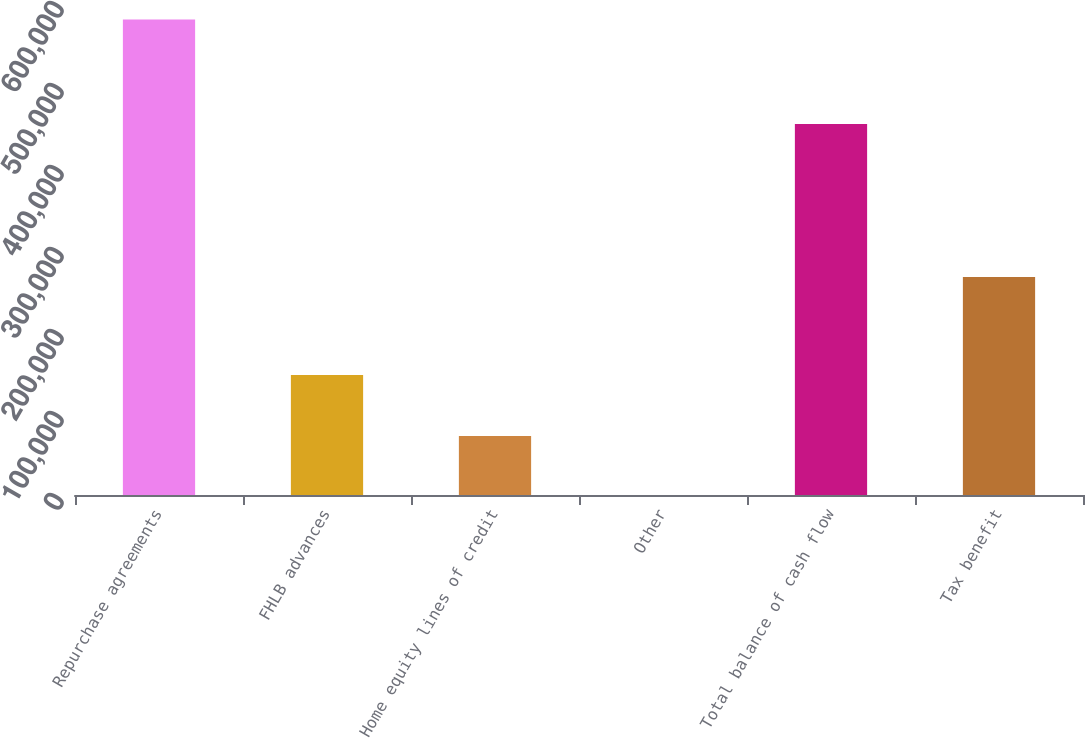<chart> <loc_0><loc_0><loc_500><loc_500><bar_chart><fcel>Repurchase agreements<fcel>FHLB advances<fcel>Home equity lines of credit<fcel>Other<fcel>Total balance of cash flow<fcel>Tax benefit<nl><fcel>579763<fcel>146253<fcel>71909<fcel>116<fcel>452341<fcel>265705<nl></chart> 